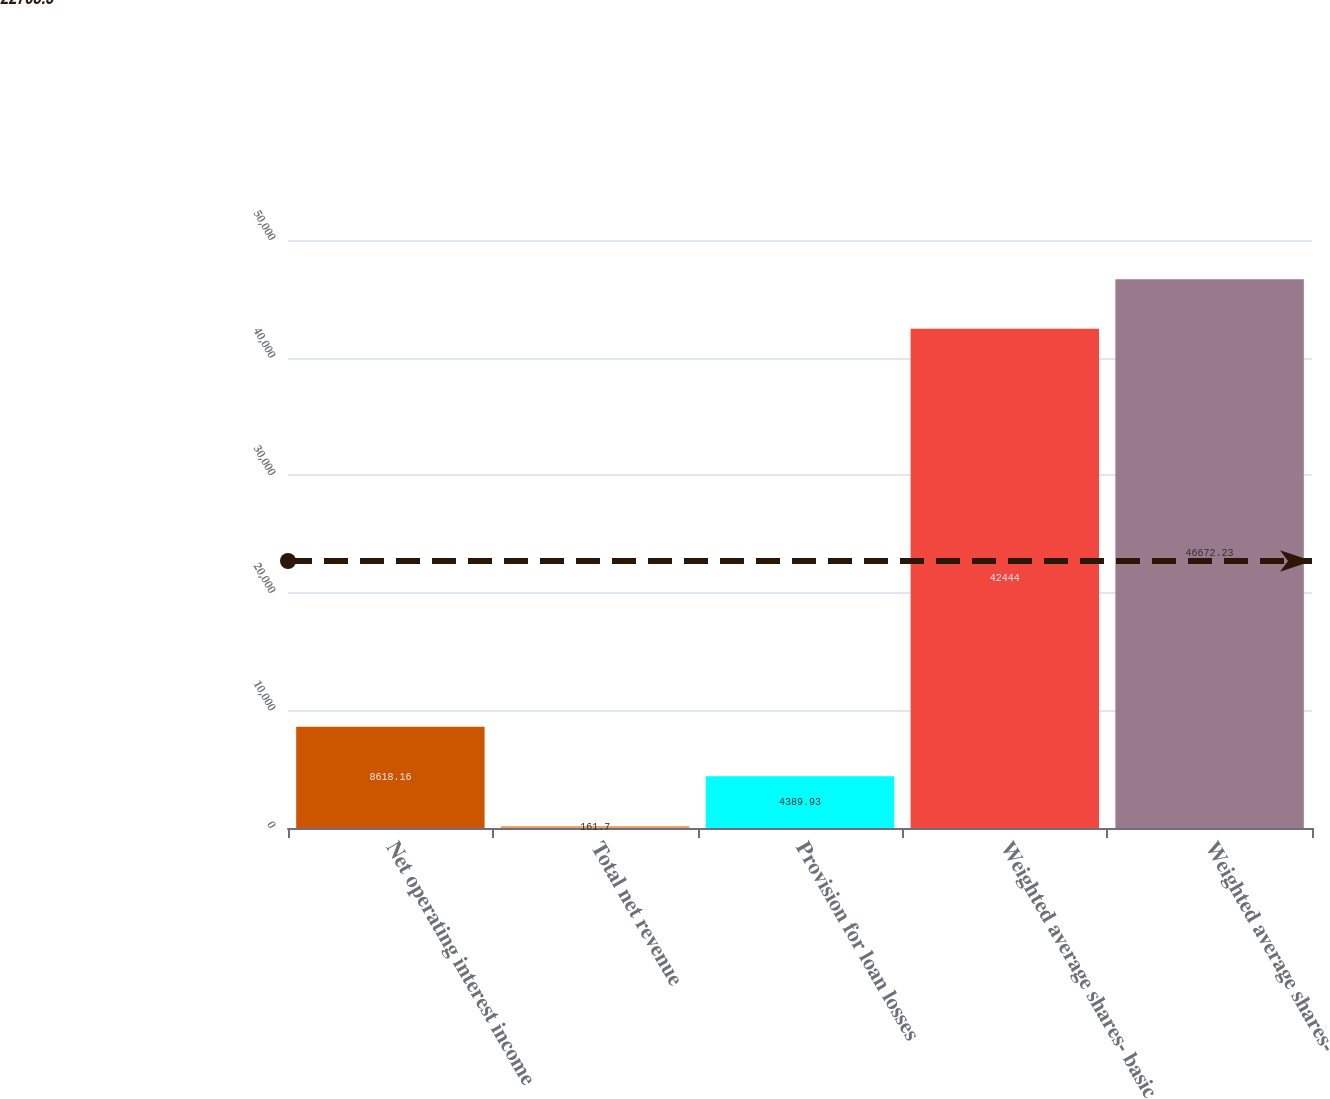<chart> <loc_0><loc_0><loc_500><loc_500><bar_chart><fcel>Net operating interest income<fcel>Total net revenue<fcel>Provision for loan losses<fcel>Weighted average shares- basic<fcel>Weighted average shares-<nl><fcel>8618.16<fcel>161.7<fcel>4389.93<fcel>42444<fcel>46672.2<nl></chart> 